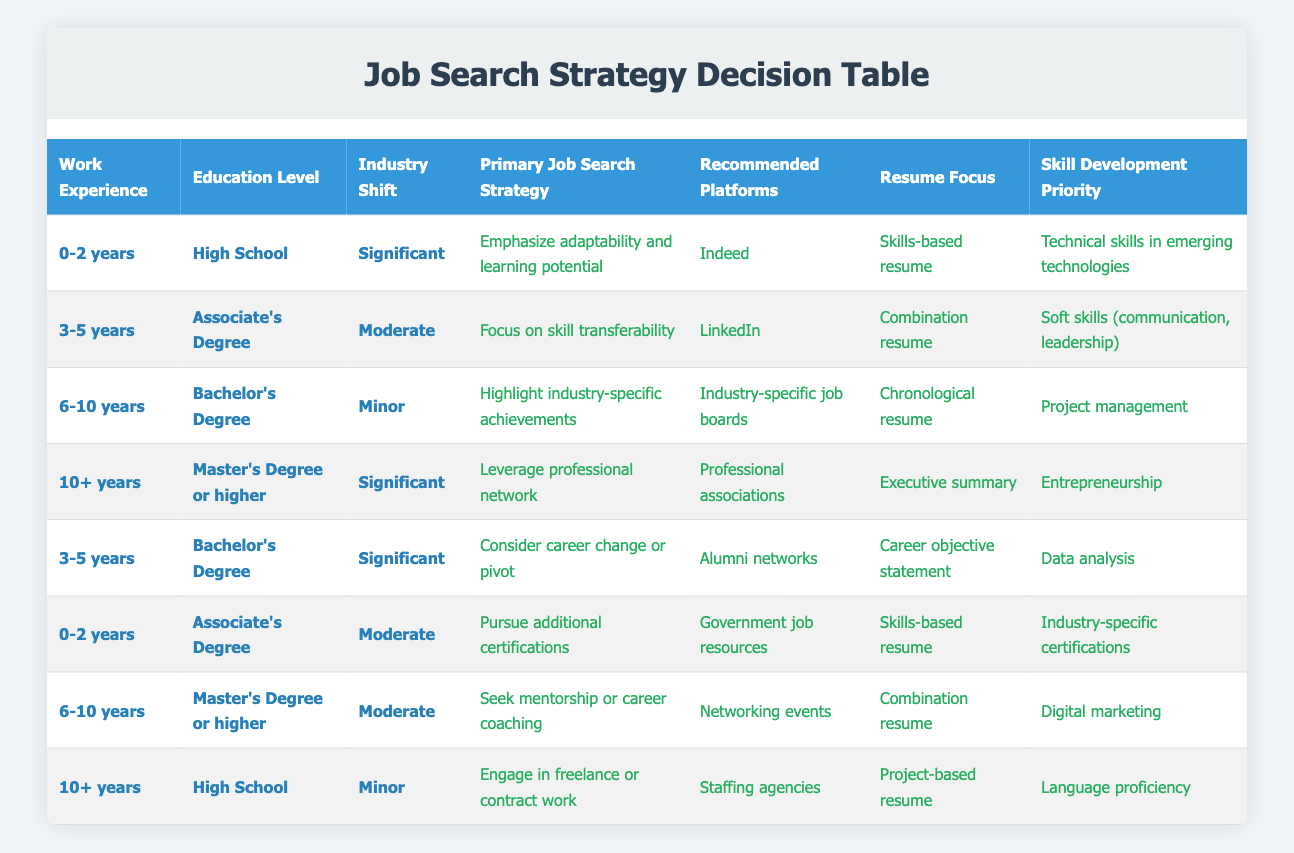What job search strategy is recommended for someone with 10+ years of experience and a Master's Degree in an industry that has undergone significant shifts? According to the table, the recommended job search strategy is to leverage your professional network with platforms like professional associations, focusing on an executive summary and entrepreneurship as the skill development priority.
Answer: Leverage professional network Which platforms are suggested for someone with 3-5 years of experience and an Associate's Degree in a moderately shifting industry? The table indicates that the recommended platform for this profile is LinkedIn, alongside focusing on skill transferability and utilizing a combination resume, with priority on soft skills for development.
Answer: LinkedIn Is a skills-based resume suggested for job seekers with 0-2 years of experience and an Associate's Degree in a moderately shifting industry? Yes, the table shows that a skills-based resume is indeed a recommended focus for individuals with these specific conditions.
Answer: Yes What skill development priority is recommended for someone with 6-10 years of experience and a Bachelor's Degree facing minor industry shifts? For this profile, the table indicates that the skill development priority should be project management, emphasizing industry-specific achievements and using an industry-specific job board for job search.
Answer: Project management How many different primary job search strategies are mentioned in the table? Counting the unique primary job search strategies listed in the table reveals a total of eight distinct strategies available to job seekers, indicating a diverse approach to job searching.
Answer: 8 What is the suggested resume focus for someone with 0-2 years of experience, a High School education, and a significant industry shift? The table specifies that the resume focus should be on a skills-based resume, emphasizing adaptability and technical skills in emerging technologies in the job market context.
Answer: Skills-based resume For job seekers with 10+ years of experience and a High School education in a minor industry shift, what additional action is suggested for their job search? The table suggests that engaging in freelance or contract work is the recommended strategy for job seekers in this demographic, along with pursuing opportunities via staffing agencies and focusing on language proficiency.
Answer: Engage in freelance or contract work What is the most common recommended job search strategy for individuals with 3-5 years of experience across different educational backgrounds? The table indicates that "Focus on skill transferability" is suggested for those with an Associate's Degree and "Consider career change or pivot" for those with a Bachelor's Degree, demonstrating varied approaches based on educational attainment.
Answer: Varies by education level 